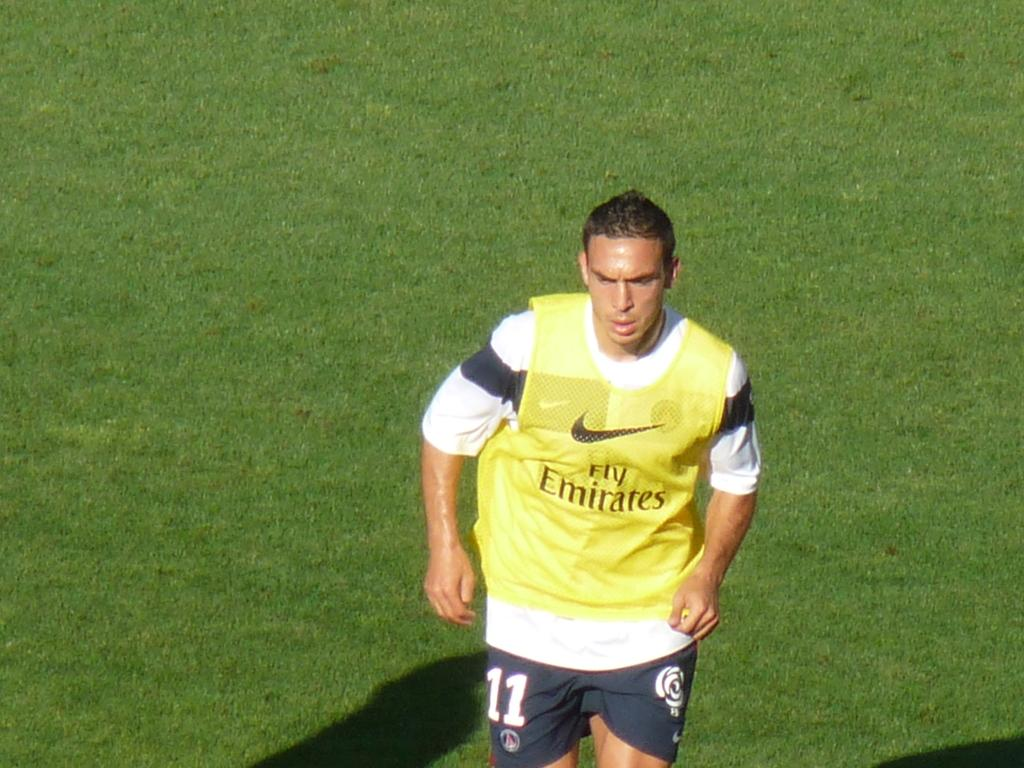What is the main subject of the subject of the image? There is a man standing in the image. What is the man standing on? The man is standing on the ground. What type of vegetation can be seen in the background of the image? There is grass visible in the background of the image. What else can be observed in the background of the image? Shadows are present in the background of the image. What are the man's hobbies, and how does he feel about them in the image? There is no information about the man's hobbies or feelings in the image. 